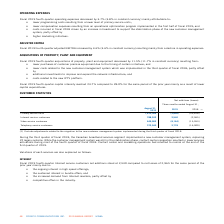According to Cogeco's financial document, Why did the Fiscal 2019 fourth-quarter Internet service customers net additions stood at 2,540 compared to net losses of 2,965 for the same period of the prior year? • the ongoing interest in high speed offerings; • the sustained interest in bundle offers; and • the increased demand from Internet resellers; partly offset by • competitive offers in the industry.. The document states: "• the ongoing interest in high speed offerings; • the sustained interest in bundle offers; and • the increased demand from Internet resellers; partly ..." Also, Why did the Fiscal 2019 fourth-quarter video service customers net losses stood at 8,164 compared to 15,953 for the same period of the prior year? Based on the financial document, the answer is • highly competitive offers in the industry; and • a changing video consumption environment; partly offset by • customers' ongoing interest in digital advanced video services; and • customers' interest in video services bundled with fast Internet offerings.. Also, Why did the Fiscal 2019 fourth-quarter telephony service customers net additions amounted to 2,778 compared to net losses 16,900 for the same period of the prior year? Based on the financial document, the answer is • more telephony bundles due to additional promotional activity in the second half of fiscal 2019; and • growth in the business sector; partly offset by • increasing wireless penetration in North America and various unlimited offers launched by wireless operators causing some customers to cancel their landline telephony services for wireless telephony services only.. Also, can you calculate: What is the increase/ (decrease) Primary service units of Net additions (losses) from 2018 to 2019? Based on the calculation: (-2,846)-(-35,818), the result is 32972. This is based on the information: "Primary service units 1,810,366 (2,846) (35,818) Primary service units 1,810,366 (2,846) (35,818)..." The key data points involved are: 2,846, 35,818. Also, can you calculate: What is the increase/ (decrease) Internet service customers of Net additions (losses) from 2018 to 2019? Based on the calculation: 2,540-(-2,965), the result is 5505. This is based on the information: "Internet service customers 788,243 2,540 (2,965) Internet service customers 788,243 2,540 (2,965)..." The key data points involved are: 2,540, 2,965. Also, can you calculate: What is the increase/ (decrease) Video service customers of Net additions (losses) from 2018 to 2019? Based on the calculation: (-8,164)-(-15,953), the result is 7789. This is based on the information: "Video service customers 649,583 (8,164) (15,953) Video service customers 649,583 (8,164) (15,953)..." The key data points involved are: 15,953, 8,164. 